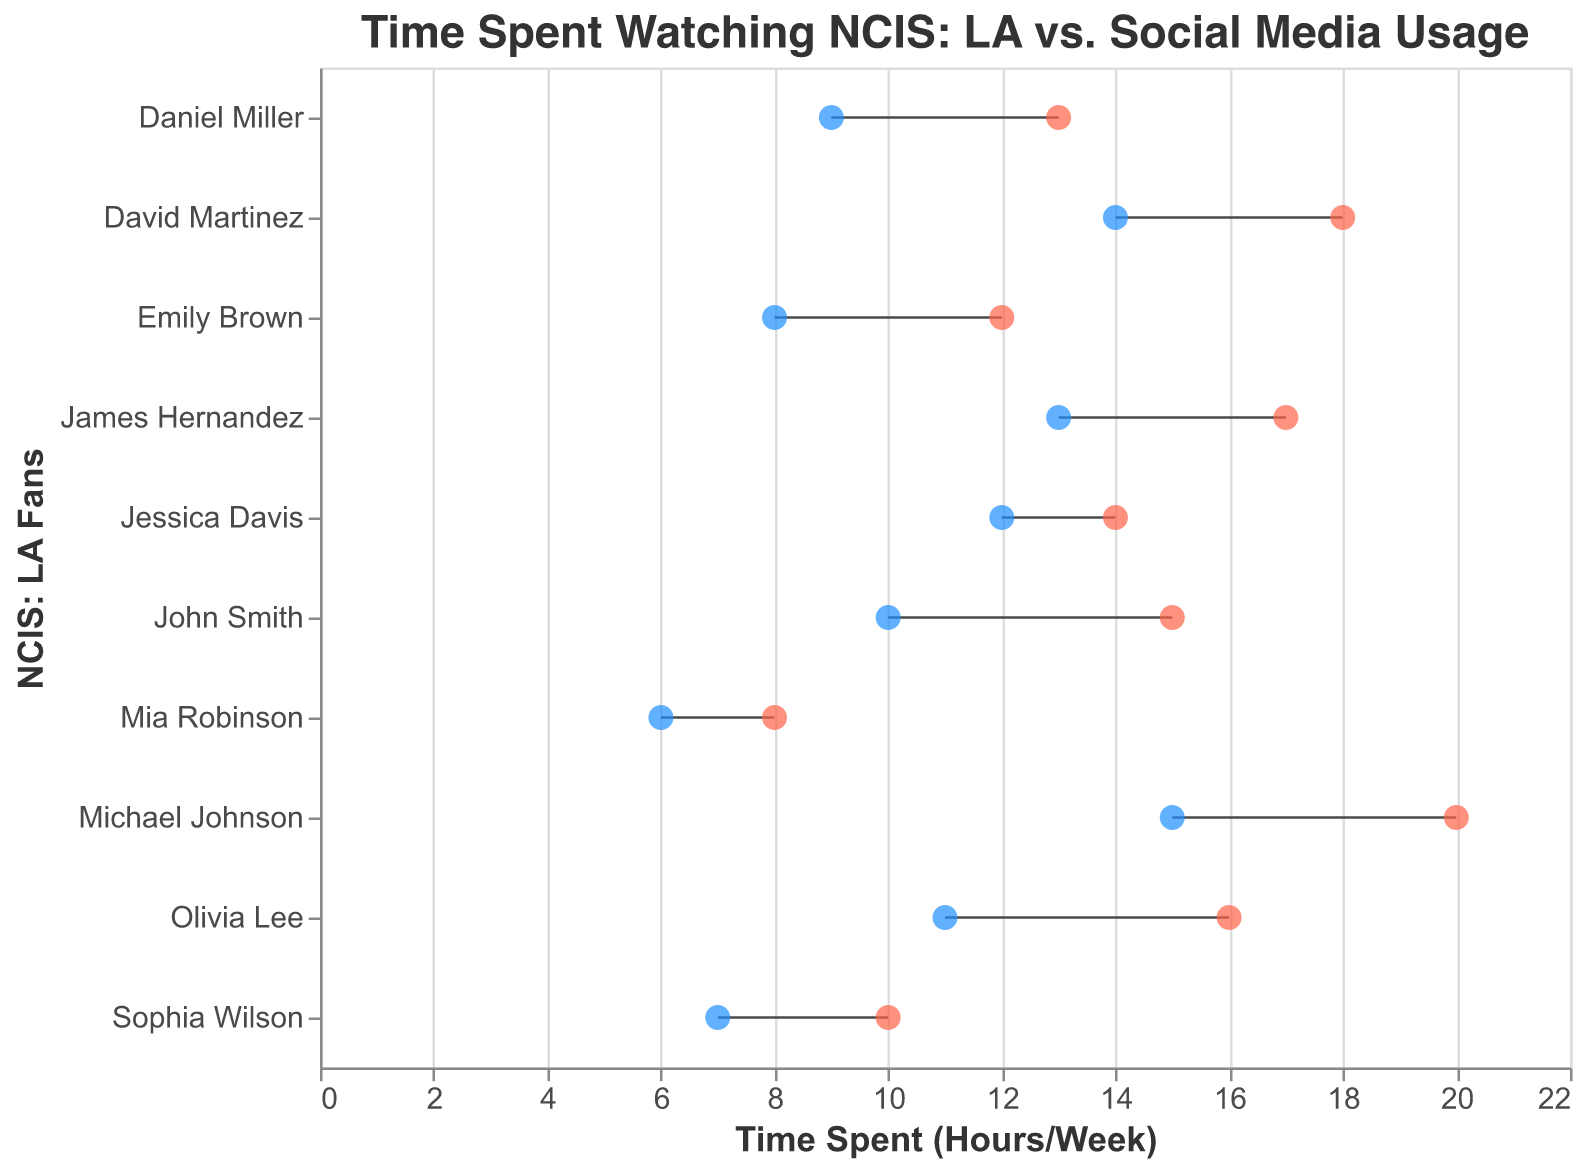What is the title of the plot? The title is displayed at the top of the figure and it summarizes the theme of the plot. The title is "Time Spent Watching NCIS: LA vs. Social Media Usage"
Answer: Time Spent Watching NCIS: LA vs. Social Media Usage How many fans are represented in the plot? Each data point on the y-axis represents a different NCIS: LA fan, so counting the number of unique names will give the answer. There are 10 fans listed on the y-axis.
Answer: 10 What are the two colors used to represent the points, and what do they signify? The plot uses two different colors for the points: blue and red. Blue represents the "Time Spent Watching NCIS LA (Hours/Week)," and red represents the "Time Spent on Social Media (Hours/Week)."
Answer: Blue and Red Which fan spends the most time watching NCIS: LA per week? By looking at the blue points (representing the time spent watching NCIS: LA) and identifying the highest value on the x-axis, we see that Michael Johnson spends 15 hours per week.
Answer: Michael Johnson Which fan has the smallest difference in time between watching NCIS: LA and being on social media? To find the smallest difference, subtract the time spent watching NCIS: LA from the time spent on social media for each fan. The smallest difference is observed by looking at the length of the dumbbells (lines between points). Mia Robinson has the smallest difference (2 hours).
Answer: Mia Robinson Who spends 13 hours watching NCIS: LA per week, and how many hours do they spend on social media? Locate the fan who has a blue point at 13 on the x-axis. James Hernandez spends 13 hours watching NCIS: LA and 17 hours on social media.
Answer: James Hernandez, 17 hours What is the total time spent watching NCIS: LA by all fans combined? Sum the times from each fan: 10 (John) + 8 (Emily) + 15 (Michael) + 12 (Jessica) + 9 (Daniel) + 7 (Sophia) + 14 (David) + 11 (Olivia) + 13 (James) + 6 (Mia) = 105 hours.
Answer: 105 hours Who spends equal time on watching NCIS: LA and social media? Identify any fan where the two points (blue and red) coincide on the horizontal axis. There's no fan who spends the same amount of time on NCIS: LA and social media.
Answer: None What is the average time spent on social media by all fans? Add the time spent on social media by each fan and divide by the number of fans: (15 + 12 + 20 + 14 + 13 + 10 + 18 + 16 + 17 + 8) / 10 = 143 / 10 = 14.3 hours/week.
Answer: 14.3 hours/week Which fan spends more time on social media compared to watching NCIS: LA? By checking all red points (social media) that appear to the right of blue points (watching NCIS: LA), we see that all fans spend more time on social media than watching NCIS: LA.
Answer: All fans 